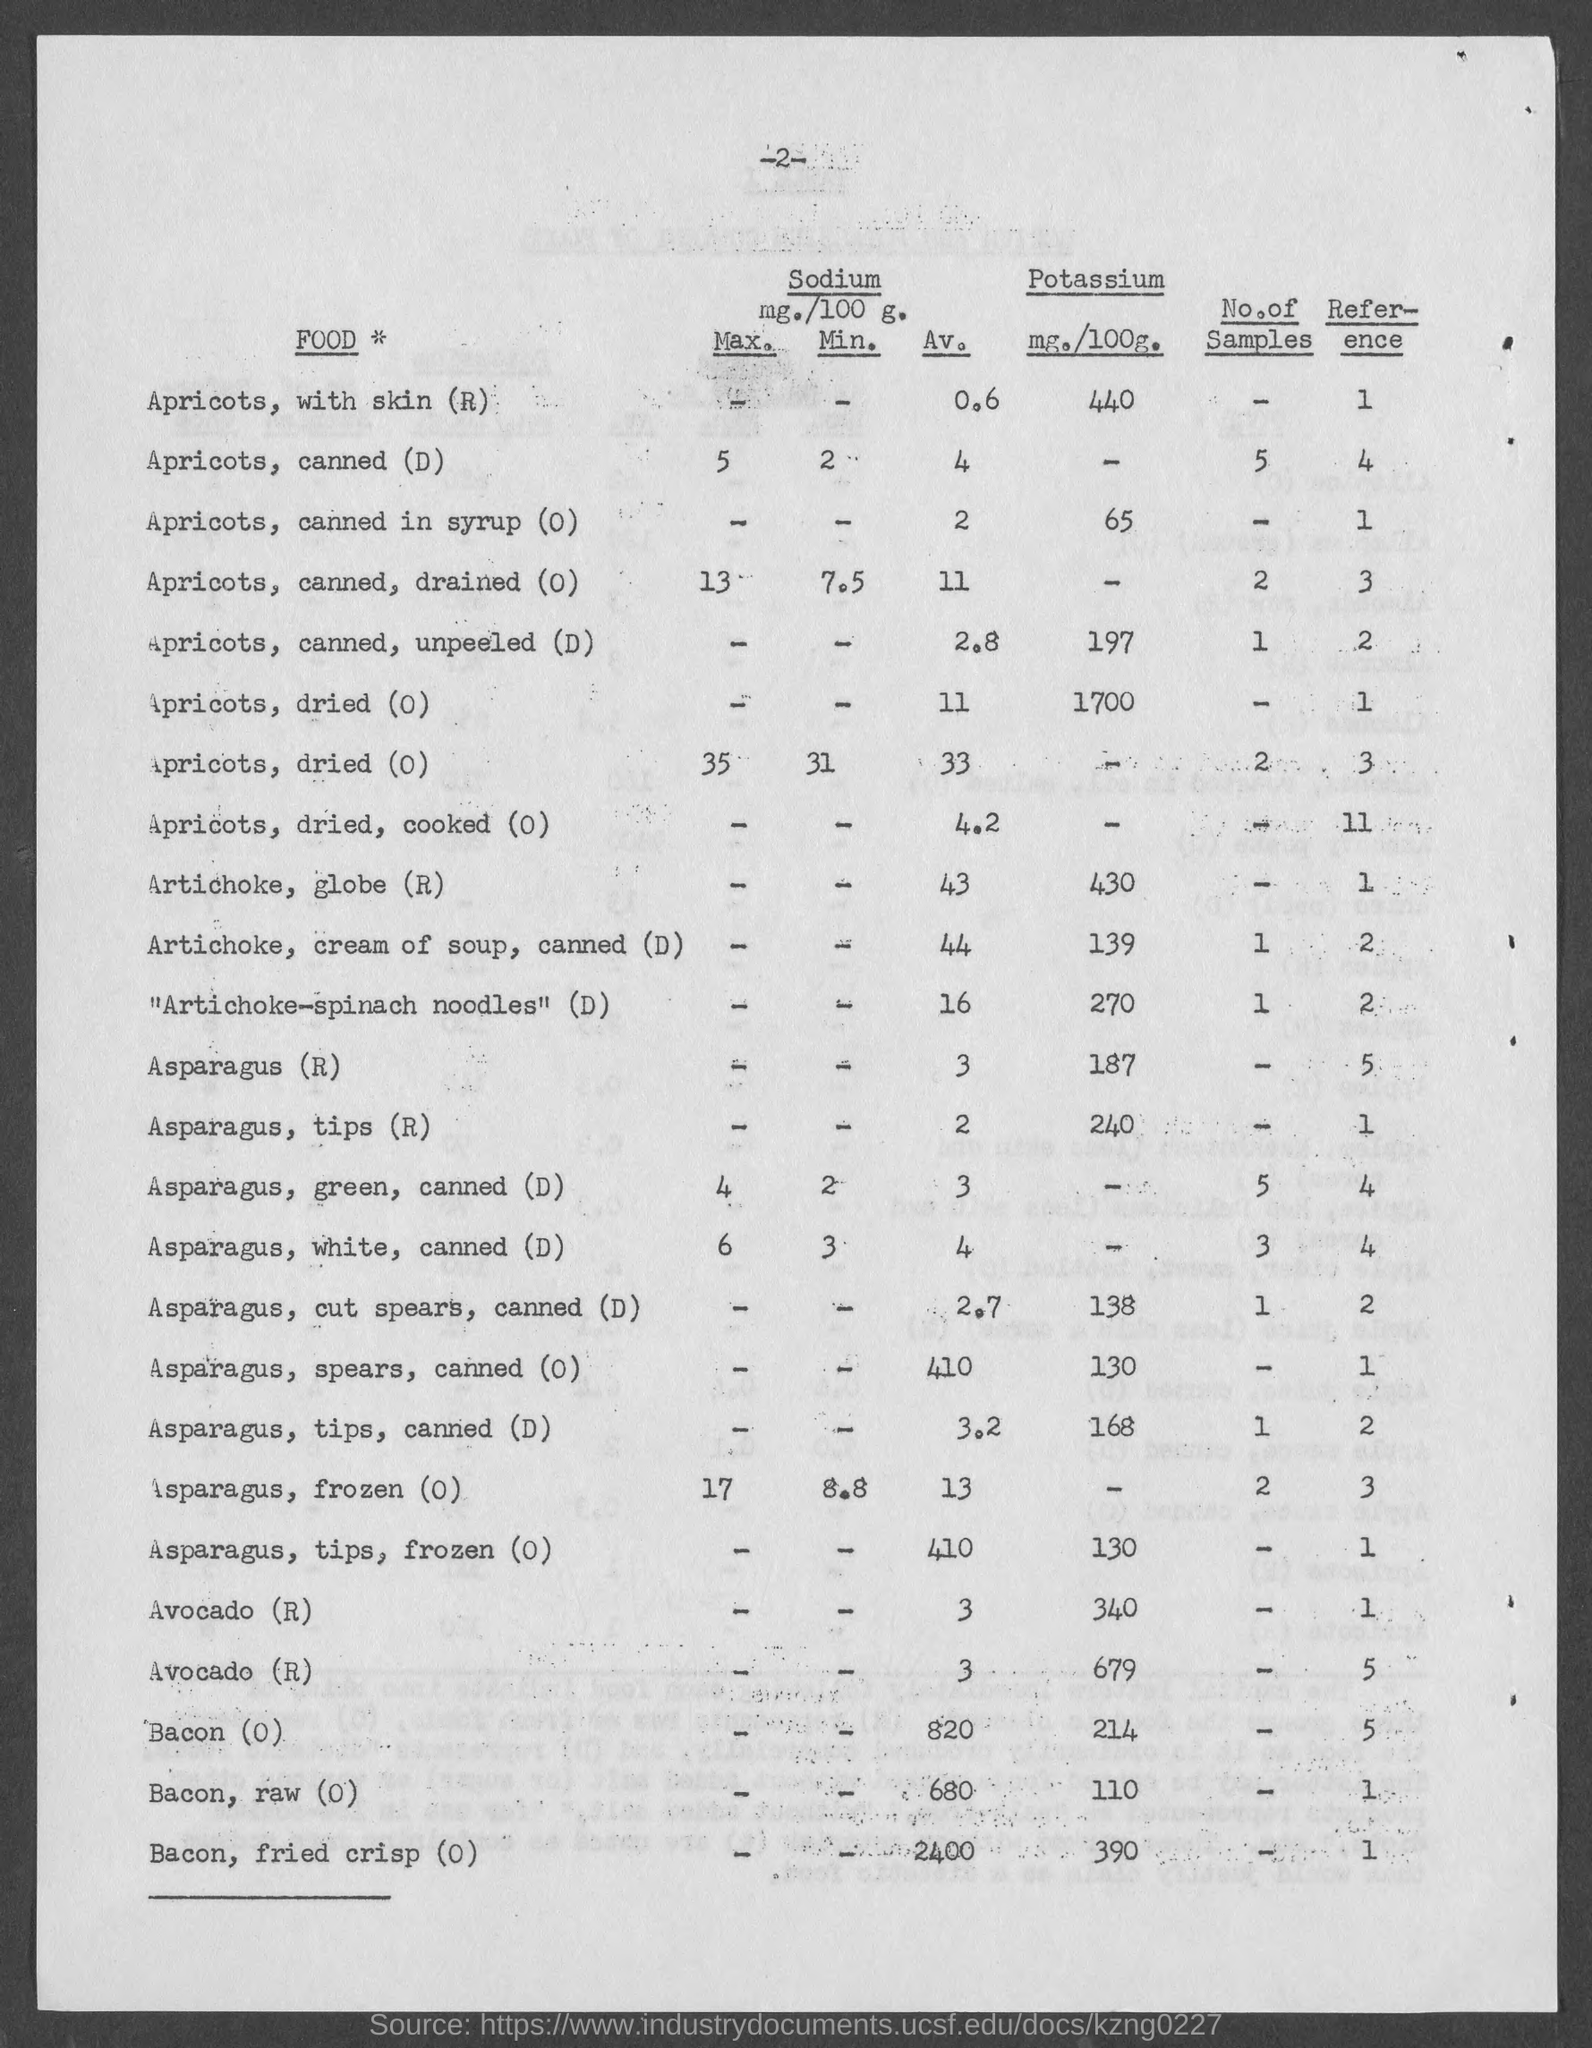Specify some key components in this picture. The amount of potassium in asparagus is 187 milligrams per 100 grams. The amount of potassium in bacon is 214 milligrams per 100 grams. The amount of potassium in 100 grams of ripe apricots, with skin, is 440 milligrams. The amount of potassium in 100 grams of canned apricots in syrup is 65 milligrams. The amount of potassium in 100 grams of globe artichoke is 430 milligrams. 